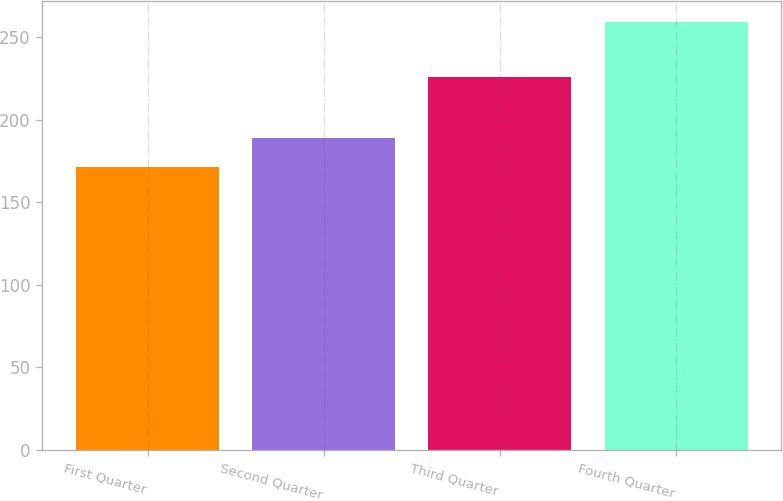Convert chart. <chart><loc_0><loc_0><loc_500><loc_500><bar_chart><fcel>First Quarter<fcel>Second Quarter<fcel>Third Quarter<fcel>Fourth Quarter<nl><fcel>171.41<fcel>188.77<fcel>225.83<fcel>259<nl></chart> 